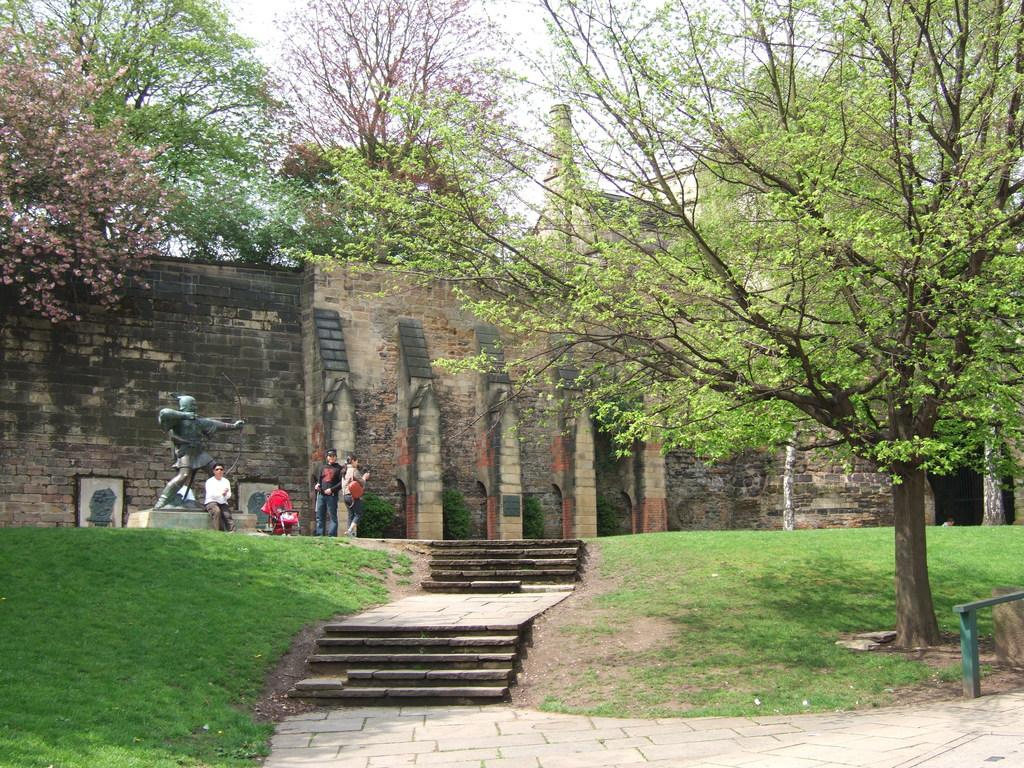What type of vegetation can be seen in the image? There is grass, plants, and trees visible in the image. What architectural feature is present in the image? There are steps and a wall in the image. What can be seen in the background of the image? There is a building and the sky visible in the background of the image. Are there any living beings in the image? Yes, there are people in the image. What other object can be seen in the image? There is a statue in the image. How many birds are perched on the statue in the image? There are no birds present in the image; it only features people, a statue, steps, a wall, grass, plants, trees, a building, and the sky. 